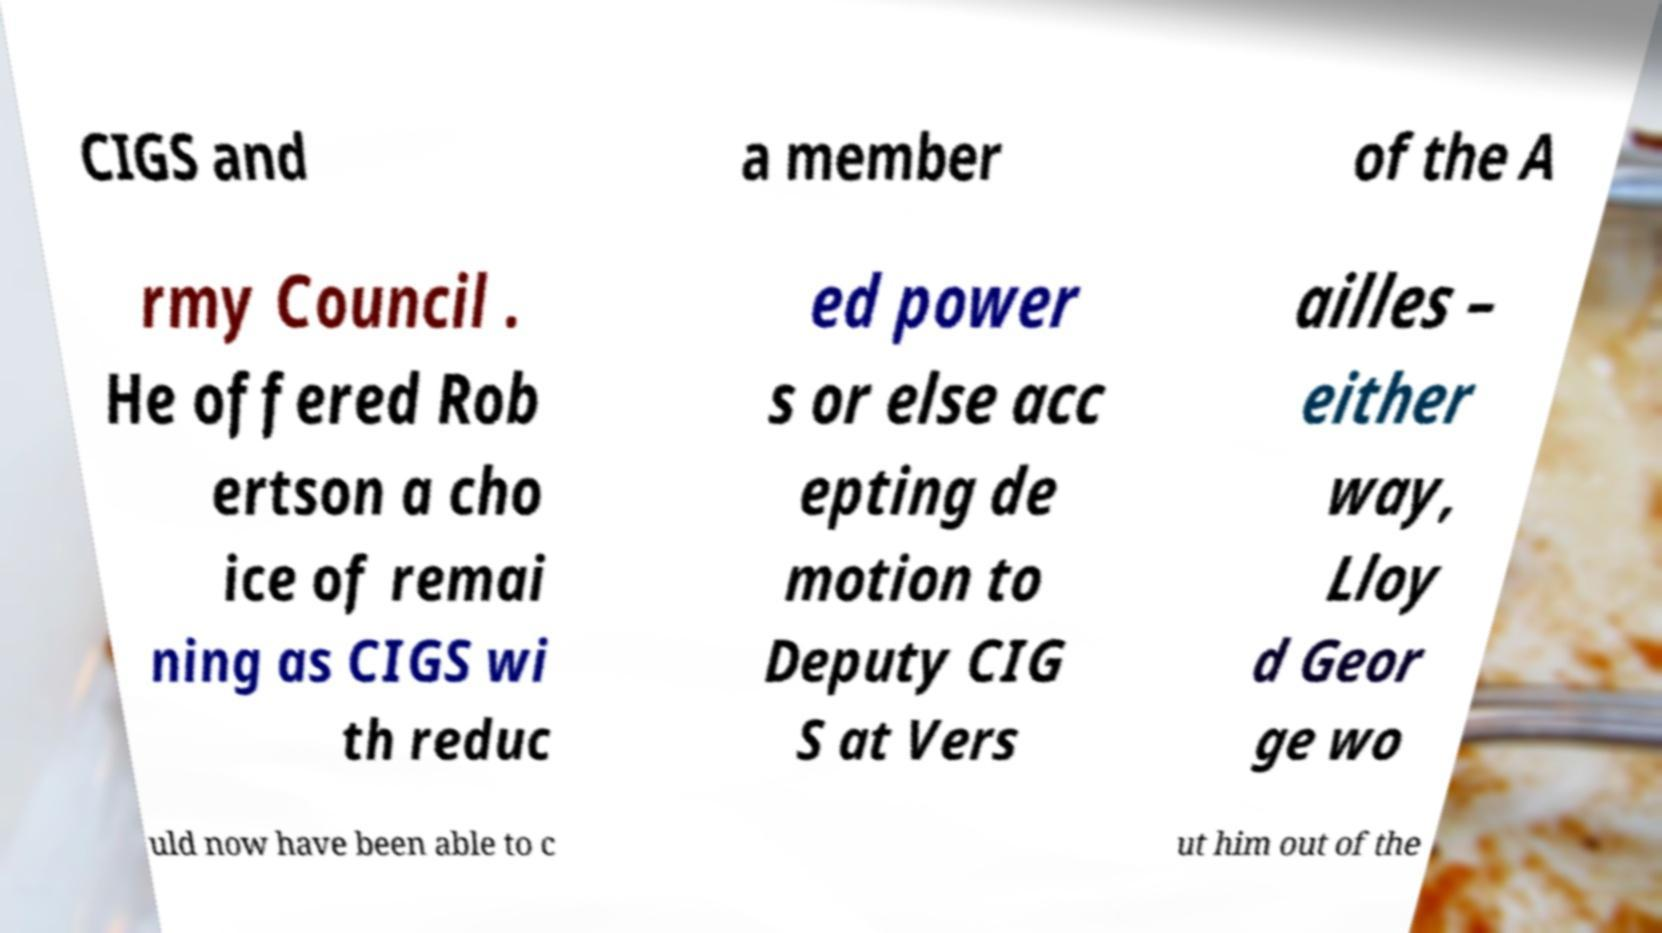Can you accurately transcribe the text from the provided image for me? CIGS and a member of the A rmy Council . He offered Rob ertson a cho ice of remai ning as CIGS wi th reduc ed power s or else acc epting de motion to Deputy CIG S at Vers ailles – either way, Lloy d Geor ge wo uld now have been able to c ut him out of the 